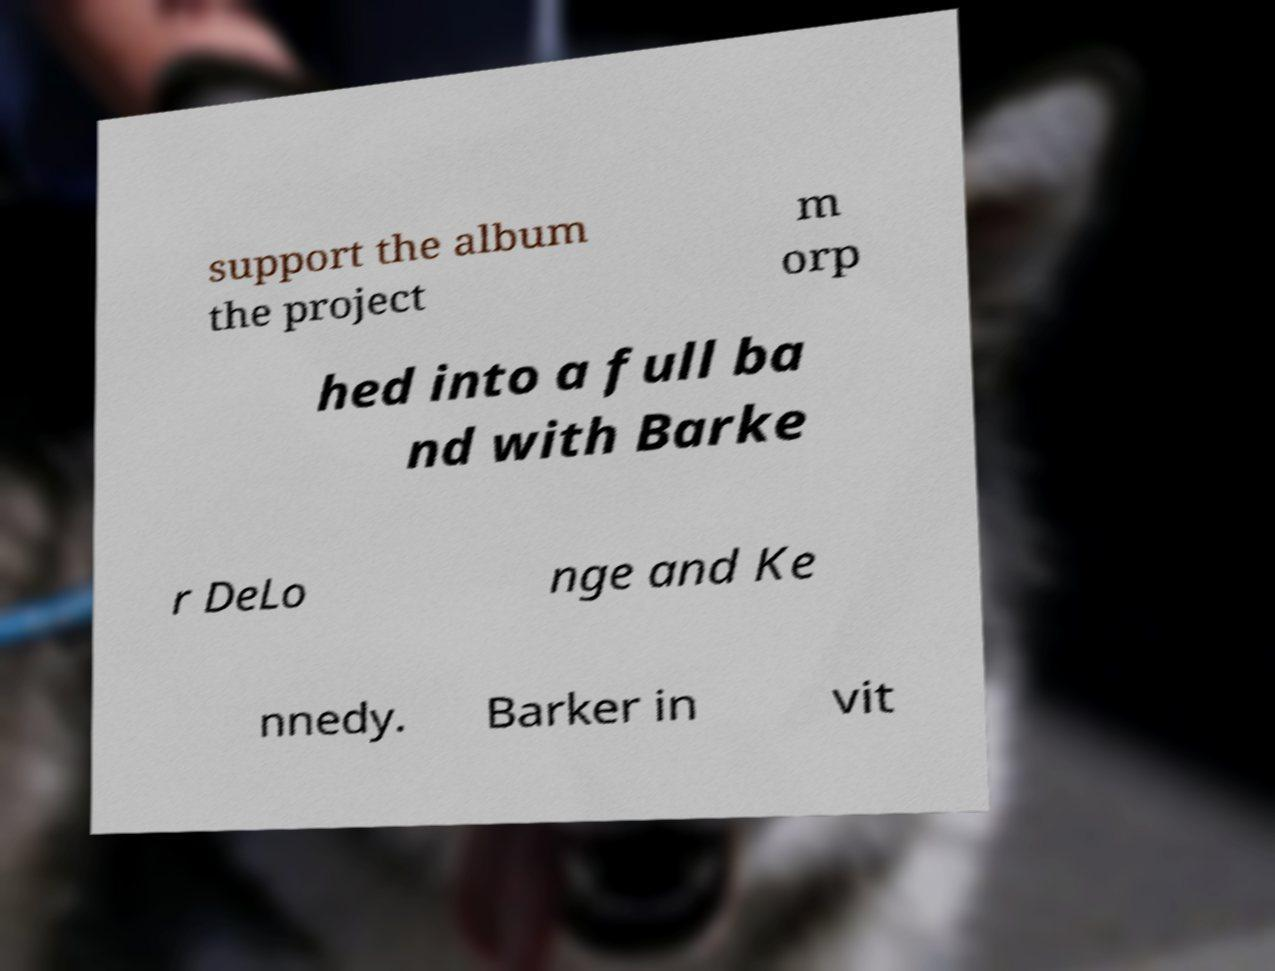Could you assist in decoding the text presented in this image and type it out clearly? support the album the project m orp hed into a full ba nd with Barke r DeLo nge and Ke nnedy. Barker in vit 